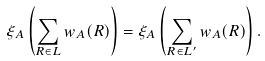Convert formula to latex. <formula><loc_0><loc_0><loc_500><loc_500>\xi _ { A } \left ( \sum _ { R \in L } { w } _ { A } ( R ) \right ) = \xi _ { A } \left ( \sum _ { R \in L ^ { \prime } } { w } _ { A } ( R ) \right ) .</formula> 